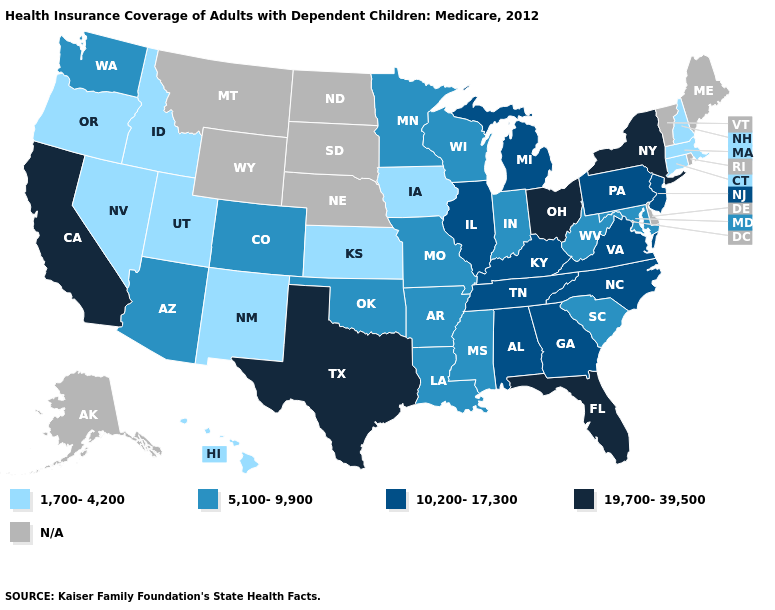Which states have the lowest value in the USA?
Short answer required. Connecticut, Hawaii, Idaho, Iowa, Kansas, Massachusetts, Nevada, New Hampshire, New Mexico, Oregon, Utah. What is the lowest value in the West?
Answer briefly. 1,700-4,200. What is the highest value in the MidWest ?
Write a very short answer. 19,700-39,500. What is the value of West Virginia?
Be succinct. 5,100-9,900. Which states have the lowest value in the USA?
Short answer required. Connecticut, Hawaii, Idaho, Iowa, Kansas, Massachusetts, Nevada, New Hampshire, New Mexico, Oregon, Utah. What is the value of Connecticut?
Give a very brief answer. 1,700-4,200. Which states hav the highest value in the South?
Short answer required. Florida, Texas. Among the states that border Nebraska , does Kansas have the highest value?
Give a very brief answer. No. What is the highest value in states that border Kentucky?
Quick response, please. 19,700-39,500. Name the states that have a value in the range 1,700-4,200?
Give a very brief answer. Connecticut, Hawaii, Idaho, Iowa, Kansas, Massachusetts, Nevada, New Hampshire, New Mexico, Oregon, Utah. What is the lowest value in states that border Georgia?
Write a very short answer. 5,100-9,900. Among the states that border Michigan , does Ohio have the highest value?
Be succinct. Yes. Name the states that have a value in the range 5,100-9,900?
Keep it brief. Arizona, Arkansas, Colorado, Indiana, Louisiana, Maryland, Minnesota, Mississippi, Missouri, Oklahoma, South Carolina, Washington, West Virginia, Wisconsin. Name the states that have a value in the range 19,700-39,500?
Answer briefly. California, Florida, New York, Ohio, Texas. 